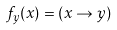Convert formula to latex. <formula><loc_0><loc_0><loc_500><loc_500>f _ { y } ( x ) = ( x \to y )</formula> 